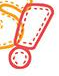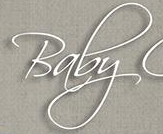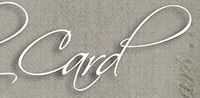Read the text content from these images in order, separated by a semicolon. !; Baby; Card 